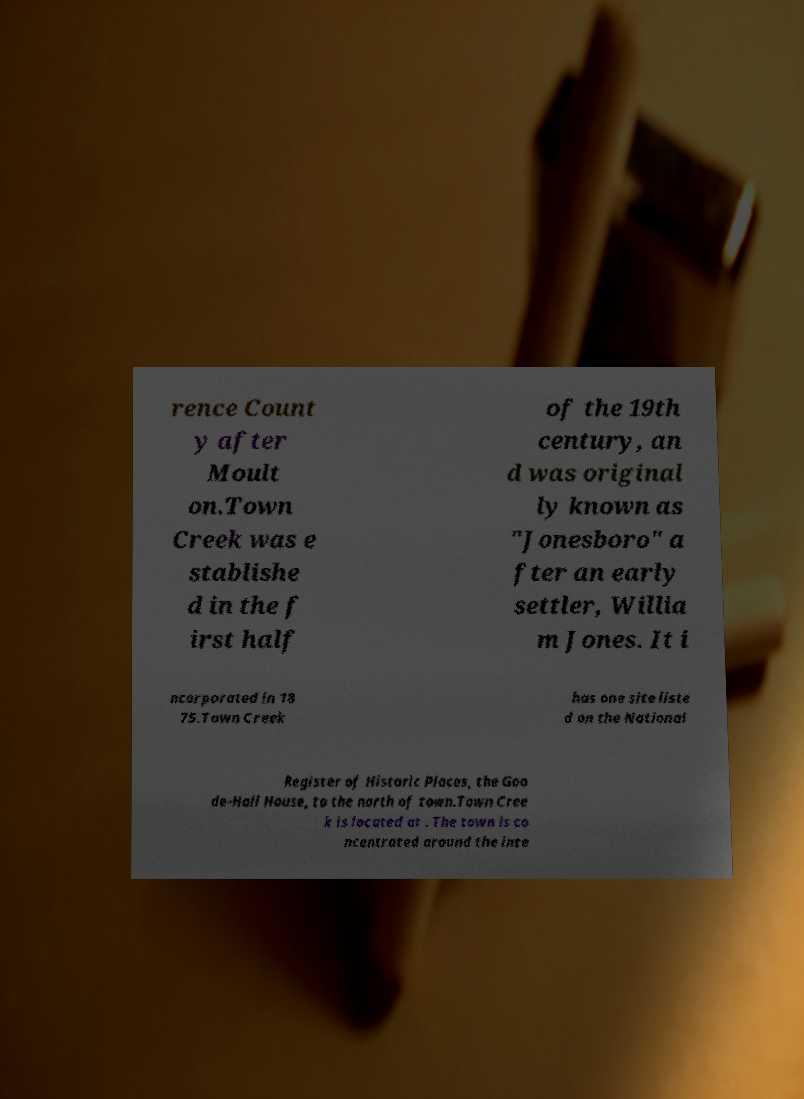There's text embedded in this image that I need extracted. Can you transcribe it verbatim? rence Count y after Moult on.Town Creek was e stablishe d in the f irst half of the 19th century, an d was original ly known as "Jonesboro" a fter an early settler, Willia m Jones. It i ncorporated in 18 75.Town Creek has one site liste d on the National Register of Historic Places, the Goo de-Hall House, to the north of town.Town Cree k is located at . The town is co ncentrated around the inte 